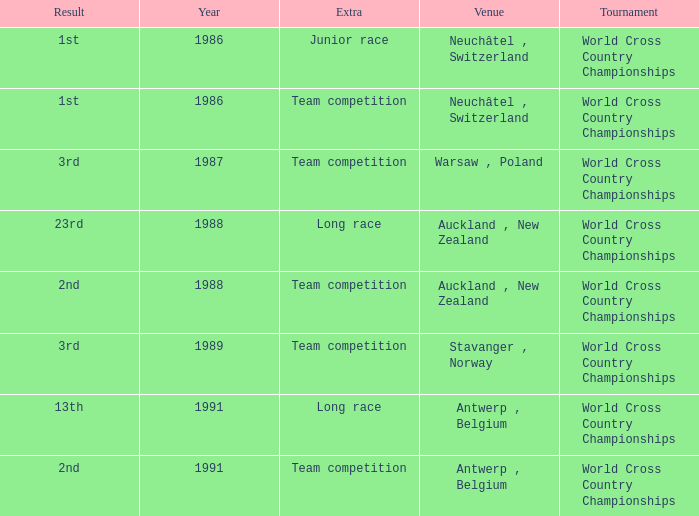Which venue had an extra of Junior Race? Neuchâtel , Switzerland. 